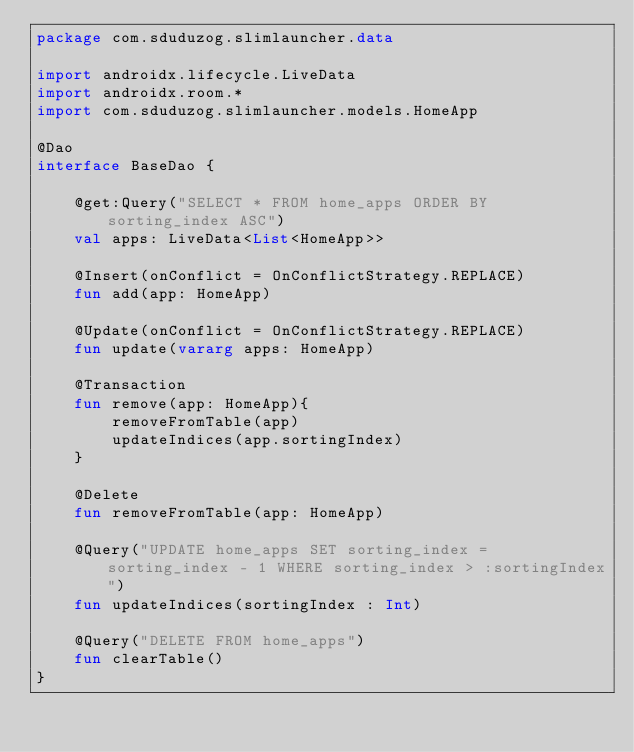Convert code to text. <code><loc_0><loc_0><loc_500><loc_500><_Kotlin_>package com.sduduzog.slimlauncher.data

import androidx.lifecycle.LiveData
import androidx.room.*
import com.sduduzog.slimlauncher.models.HomeApp

@Dao
interface BaseDao {

    @get:Query("SELECT * FROM home_apps ORDER BY sorting_index ASC")
    val apps: LiveData<List<HomeApp>>

    @Insert(onConflict = OnConflictStrategy.REPLACE)
    fun add(app: HomeApp)

    @Update(onConflict = OnConflictStrategy.REPLACE)
    fun update(vararg apps: HomeApp)

    @Transaction
    fun remove(app: HomeApp){
        removeFromTable(app)
        updateIndices(app.sortingIndex)
    }

    @Delete
    fun removeFromTable(app: HomeApp)

    @Query("UPDATE home_apps SET sorting_index = sorting_index - 1 WHERE sorting_index > :sortingIndex")
    fun updateIndices(sortingIndex : Int)

    @Query("DELETE FROM home_apps")
    fun clearTable()
}</code> 